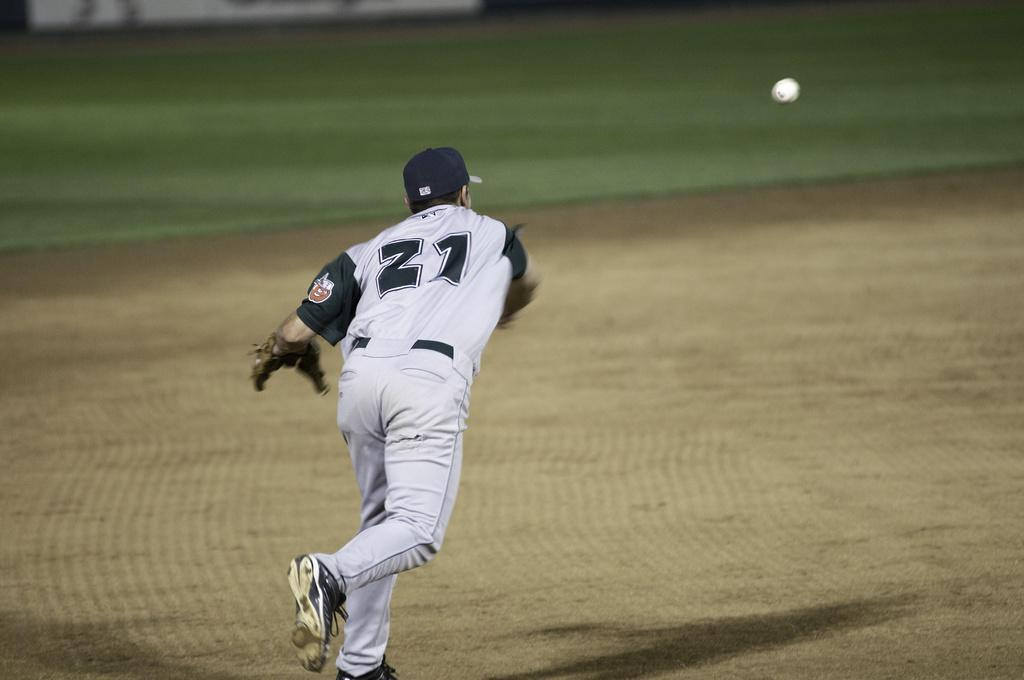<image>
Offer a succinct explanation of the picture presented. Number 21 wearing a white jersey, throws a baseball across the field. 